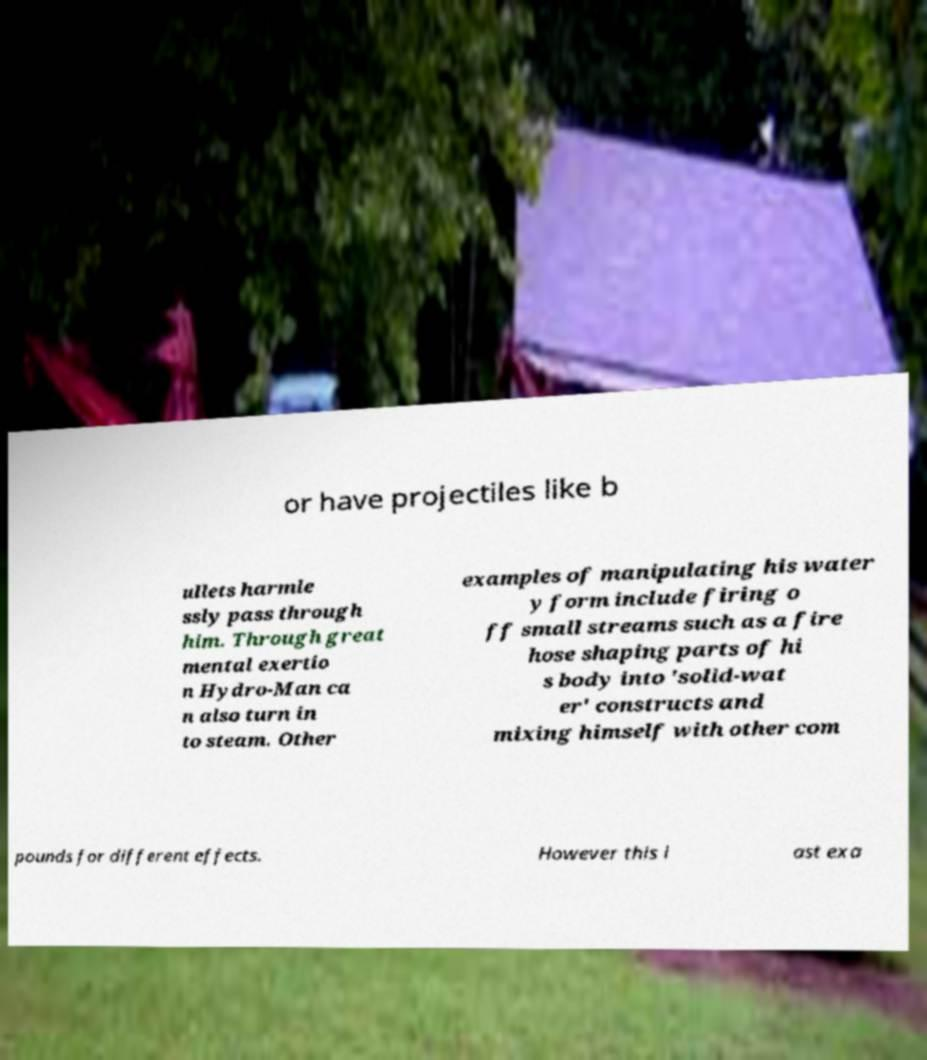There's text embedded in this image that I need extracted. Can you transcribe it verbatim? or have projectiles like b ullets harmle ssly pass through him. Through great mental exertio n Hydro-Man ca n also turn in to steam. Other examples of manipulating his water y form include firing o ff small streams such as a fire hose shaping parts of hi s body into 'solid-wat er' constructs and mixing himself with other com pounds for different effects. However this l ast exa 